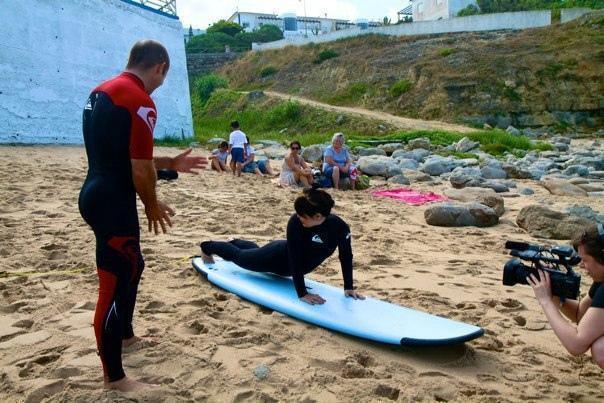How many people are there?
Give a very brief answer. 3. How many tea cups are in this picture?
Give a very brief answer. 0. 